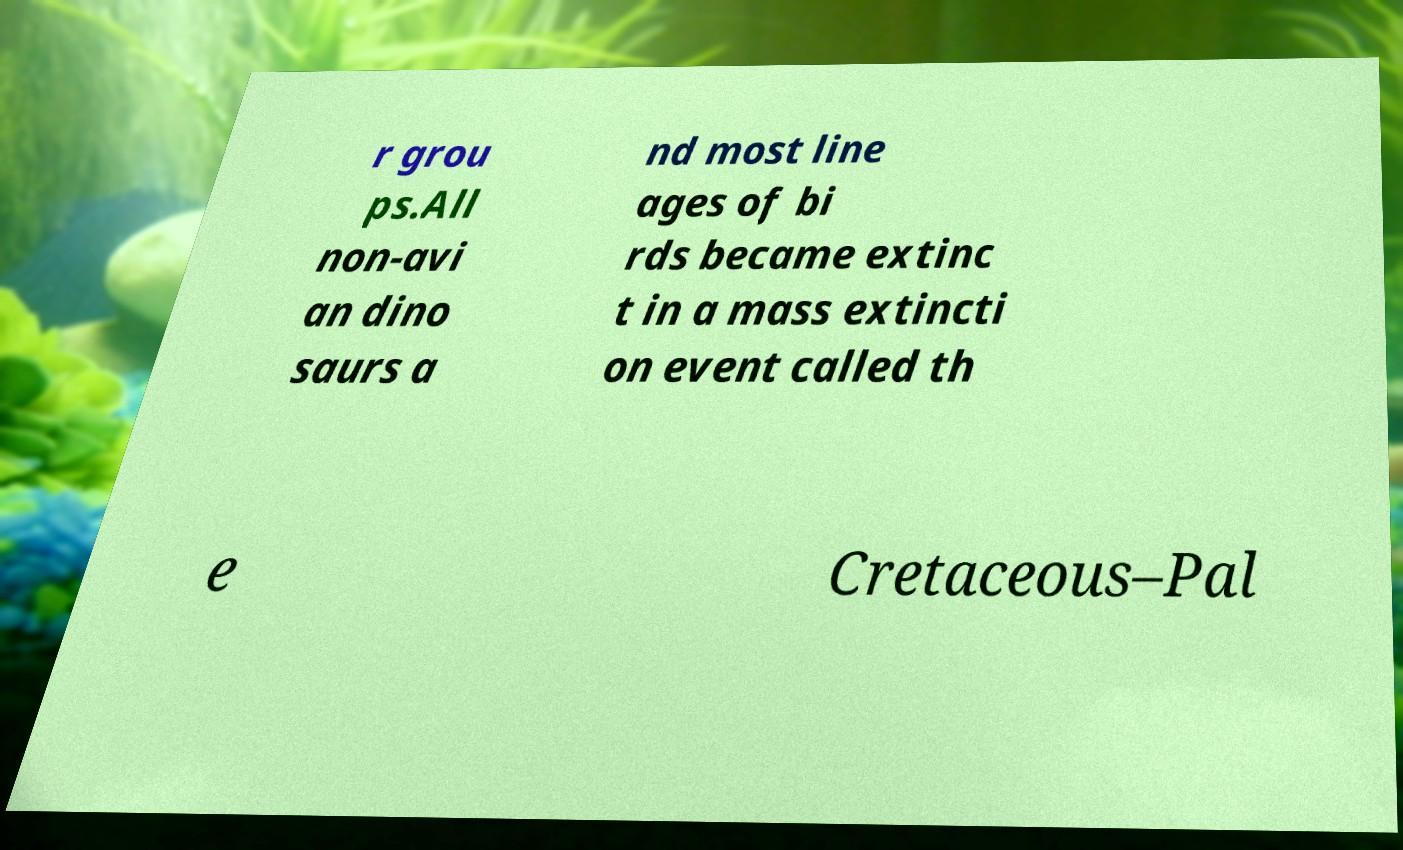For documentation purposes, I need the text within this image transcribed. Could you provide that? r grou ps.All non-avi an dino saurs a nd most line ages of bi rds became extinc t in a mass extincti on event called th e Cretaceous–Pal 